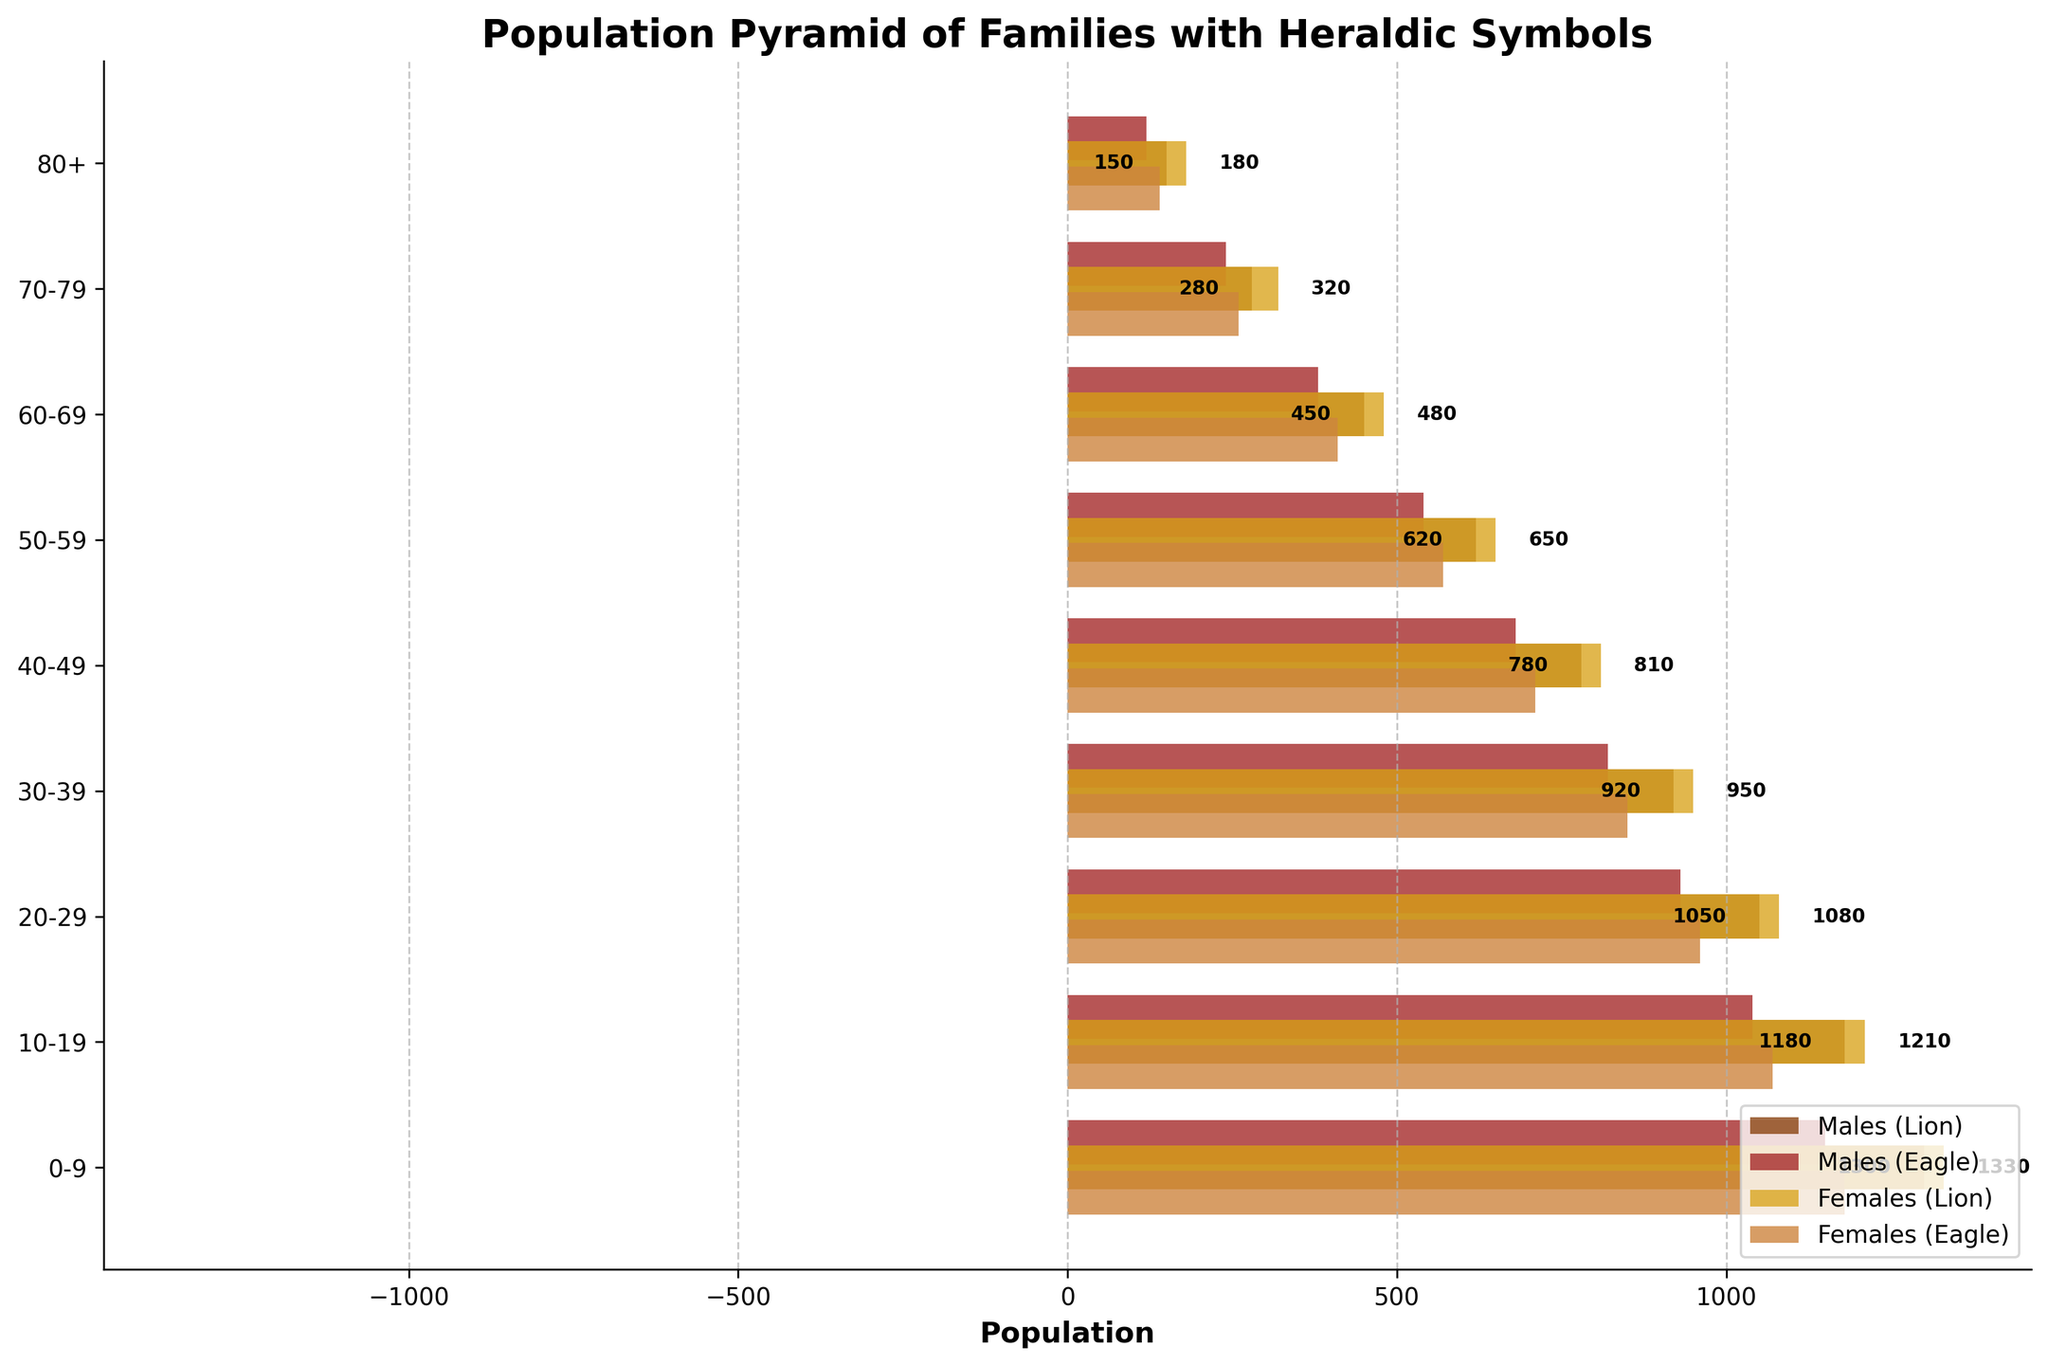What's the title of the figure? The title of the figure is displayed at the center top of the plot.
Answer: Population Pyramid of Families with Heraldic Symbols What is the color used to represent females with a Lion Crest? By looking at the colored bars representing different demographics, females with a Lion Crest are represented by a golden color.
Answer: golden How many age groups are displayed in the figure? Counting the number of categories along the y-axis provides the number of age groups shown in the figure.
Answer: 9 Which demographic group has the largest population in the 10-19 age group? The demographic with the largest bar in the 10-19 age group will indicate the group with the largest population. This group is the females with the Lion Crest.
Answer: females with the Lion Crest What's the total population of males with a Lion Crest aged 40-49? Reading the value directly from the x-axis for males with a Lion Crest in the 40-49 age group and converting it from the negative value to a positive number.
Answer: 780 Compare the populations of males with a Lion Crest and males with an Eagle Crest in the 50-59 age group. Which is higher? By comparing the length of the horizontal bars for males with Lion and Eagle Crest in the 50-59 age group, males with a Lion Crest have a longer bar.
Answer: males with a Lion Crest What is the difference in population between females with a Lion Crest and females with an Eagle Crest in the 0-9 age group? Subtracting the population values of females with an Eagle Crest from females with a Lion Crest in the 0-9 age group provides the difference.
Answer: 150 Amongst all age groups, which demographic shows the smallest population? Identifying the smallest population by comparing the lengths of the horizontal bars across all age groups and demographics reveals that males with an Eagle Crest in the 80+ age group have the smallest population.
Answer: males with an Eagle Crest in the 80+ age group What is the cumulative population of all males bearing Lion and Eagle Crests in the 20-29 age group? Summing up the absolute values of the population of males with Lion Crest and Eagle Crest within the 20-29 age group derives the cumulative population.
Answer: 1980 How do the populations of females with Lion and Eagle Crests change from the 60-69 age group to the 50-59 age group? Observing the lengths of the bars for females with Lion and Eagle Crests in the age groups 60-69 and 50-59, both populations show an increase in the number of individuals.
Answer: increased 